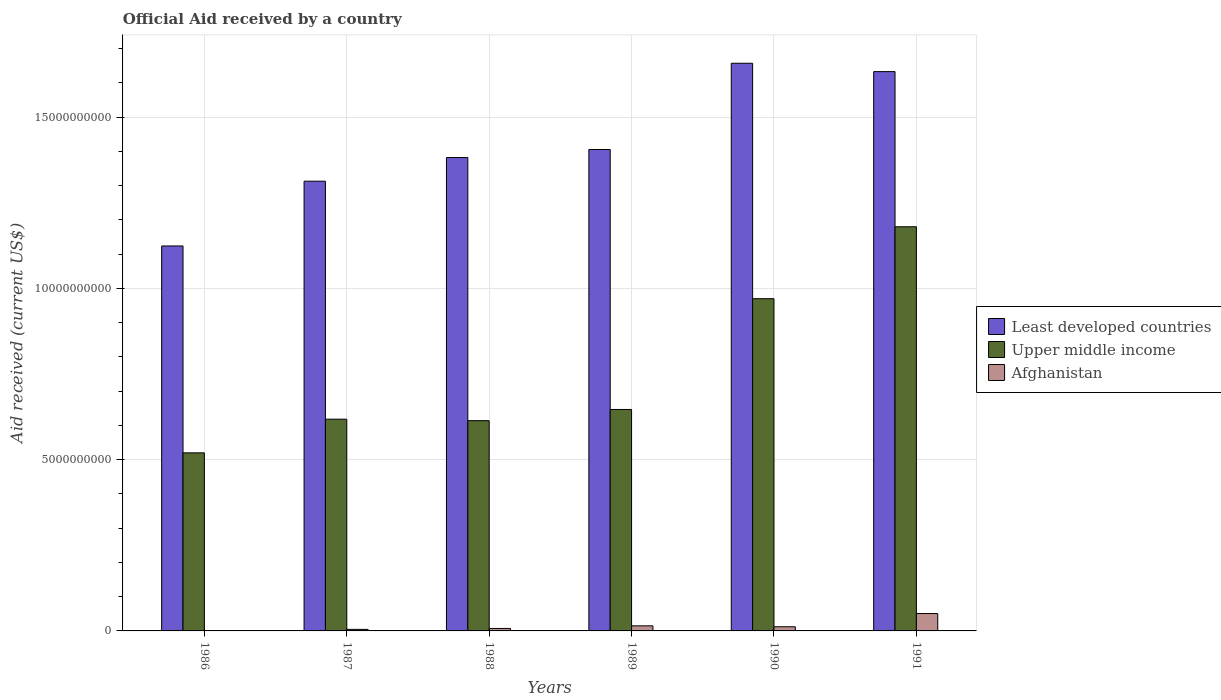How many groups of bars are there?
Your response must be concise. 6. Are the number of bars per tick equal to the number of legend labels?
Provide a succinct answer. Yes. What is the label of the 3rd group of bars from the left?
Make the answer very short. 1988. What is the net official aid received in Upper middle income in 1987?
Provide a short and direct response. 6.18e+09. Across all years, what is the maximum net official aid received in Afghanistan?
Your answer should be very brief. 5.08e+08. Across all years, what is the minimum net official aid received in Upper middle income?
Give a very brief answer. 5.20e+09. In which year was the net official aid received in Least developed countries maximum?
Your response must be concise. 1990. In which year was the net official aid received in Upper middle income minimum?
Your answer should be very brief. 1986. What is the total net official aid received in Afghanistan in the graph?
Make the answer very short. 8.97e+08. What is the difference between the net official aid received in Afghanistan in 1989 and that in 1990?
Keep it short and to the point. 2.66e+07. What is the difference between the net official aid received in Upper middle income in 1986 and the net official aid received in Least developed countries in 1989?
Keep it short and to the point. -8.86e+09. What is the average net official aid received in Upper middle income per year?
Provide a succinct answer. 7.58e+09. In the year 1989, what is the difference between the net official aid received in Afghanistan and net official aid received in Least developed countries?
Ensure brevity in your answer.  -1.39e+1. In how many years, is the net official aid received in Upper middle income greater than 1000000000 US$?
Ensure brevity in your answer.  6. What is the ratio of the net official aid received in Least developed countries in 1987 to that in 1991?
Ensure brevity in your answer.  0.8. What is the difference between the highest and the second highest net official aid received in Upper middle income?
Your response must be concise. 2.10e+09. What is the difference between the highest and the lowest net official aid received in Least developed countries?
Give a very brief answer. 5.34e+09. In how many years, is the net official aid received in Afghanistan greater than the average net official aid received in Afghanistan taken over all years?
Keep it short and to the point. 1. What does the 1st bar from the left in 1990 represents?
Offer a terse response. Least developed countries. What does the 2nd bar from the right in 1988 represents?
Your response must be concise. Upper middle income. How many bars are there?
Your answer should be compact. 18. What is the difference between two consecutive major ticks on the Y-axis?
Make the answer very short. 5.00e+09. How are the legend labels stacked?
Your response must be concise. Vertical. What is the title of the graph?
Your answer should be very brief. Official Aid received by a country. Does "Andorra" appear as one of the legend labels in the graph?
Your response must be concise. No. What is the label or title of the Y-axis?
Your answer should be compact. Aid received (current US$). What is the Aid received (current US$) in Least developed countries in 1986?
Make the answer very short. 1.12e+1. What is the Aid received (current US$) in Upper middle income in 1986?
Offer a very short reply. 5.20e+09. What is the Aid received (current US$) in Afghanistan in 1986?
Offer a terse response. 1.91e+06. What is the Aid received (current US$) of Least developed countries in 1987?
Your response must be concise. 1.31e+1. What is the Aid received (current US$) in Upper middle income in 1987?
Keep it short and to the point. 6.18e+09. What is the Aid received (current US$) in Afghanistan in 1987?
Keep it short and to the point. 4.53e+07. What is the Aid received (current US$) of Least developed countries in 1988?
Keep it short and to the point. 1.38e+1. What is the Aid received (current US$) of Upper middle income in 1988?
Your answer should be very brief. 6.14e+09. What is the Aid received (current US$) of Afghanistan in 1988?
Keep it short and to the point. 7.24e+07. What is the Aid received (current US$) in Least developed countries in 1989?
Provide a succinct answer. 1.41e+1. What is the Aid received (current US$) of Upper middle income in 1989?
Your answer should be compact. 6.47e+09. What is the Aid received (current US$) of Afghanistan in 1989?
Give a very brief answer. 1.48e+08. What is the Aid received (current US$) of Least developed countries in 1990?
Offer a terse response. 1.66e+1. What is the Aid received (current US$) of Upper middle income in 1990?
Your answer should be compact. 9.70e+09. What is the Aid received (current US$) of Afghanistan in 1990?
Ensure brevity in your answer.  1.22e+08. What is the Aid received (current US$) of Least developed countries in 1991?
Your answer should be compact. 1.63e+1. What is the Aid received (current US$) of Upper middle income in 1991?
Provide a short and direct response. 1.18e+1. What is the Aid received (current US$) in Afghanistan in 1991?
Your answer should be very brief. 5.08e+08. Across all years, what is the maximum Aid received (current US$) in Least developed countries?
Make the answer very short. 1.66e+1. Across all years, what is the maximum Aid received (current US$) of Upper middle income?
Your answer should be compact. 1.18e+1. Across all years, what is the maximum Aid received (current US$) in Afghanistan?
Offer a very short reply. 5.08e+08. Across all years, what is the minimum Aid received (current US$) of Least developed countries?
Provide a succinct answer. 1.12e+1. Across all years, what is the minimum Aid received (current US$) in Upper middle income?
Make the answer very short. 5.20e+09. Across all years, what is the minimum Aid received (current US$) in Afghanistan?
Keep it short and to the point. 1.91e+06. What is the total Aid received (current US$) of Least developed countries in the graph?
Make the answer very short. 8.52e+1. What is the total Aid received (current US$) of Upper middle income in the graph?
Your response must be concise. 4.55e+1. What is the total Aid received (current US$) of Afghanistan in the graph?
Provide a short and direct response. 8.97e+08. What is the difference between the Aid received (current US$) of Least developed countries in 1986 and that in 1987?
Your response must be concise. -1.89e+09. What is the difference between the Aid received (current US$) in Upper middle income in 1986 and that in 1987?
Offer a terse response. -9.83e+08. What is the difference between the Aid received (current US$) of Afghanistan in 1986 and that in 1987?
Keep it short and to the point. -4.34e+07. What is the difference between the Aid received (current US$) of Least developed countries in 1986 and that in 1988?
Your answer should be very brief. -2.58e+09. What is the difference between the Aid received (current US$) of Upper middle income in 1986 and that in 1988?
Provide a short and direct response. -9.40e+08. What is the difference between the Aid received (current US$) in Afghanistan in 1986 and that in 1988?
Your answer should be very brief. -7.04e+07. What is the difference between the Aid received (current US$) of Least developed countries in 1986 and that in 1989?
Your answer should be compact. -2.82e+09. What is the difference between the Aid received (current US$) in Upper middle income in 1986 and that in 1989?
Offer a very short reply. -1.27e+09. What is the difference between the Aid received (current US$) of Afghanistan in 1986 and that in 1989?
Keep it short and to the point. -1.46e+08. What is the difference between the Aid received (current US$) in Least developed countries in 1986 and that in 1990?
Provide a short and direct response. -5.34e+09. What is the difference between the Aid received (current US$) of Upper middle income in 1986 and that in 1990?
Keep it short and to the point. -4.50e+09. What is the difference between the Aid received (current US$) of Afghanistan in 1986 and that in 1990?
Make the answer very short. -1.20e+08. What is the difference between the Aid received (current US$) of Least developed countries in 1986 and that in 1991?
Provide a short and direct response. -5.09e+09. What is the difference between the Aid received (current US$) in Upper middle income in 1986 and that in 1991?
Ensure brevity in your answer.  -6.60e+09. What is the difference between the Aid received (current US$) in Afghanistan in 1986 and that in 1991?
Keep it short and to the point. -5.06e+08. What is the difference between the Aid received (current US$) in Least developed countries in 1987 and that in 1988?
Provide a short and direct response. -6.90e+08. What is the difference between the Aid received (current US$) of Upper middle income in 1987 and that in 1988?
Offer a terse response. 4.35e+07. What is the difference between the Aid received (current US$) in Afghanistan in 1987 and that in 1988?
Your response must be concise. -2.71e+07. What is the difference between the Aid received (current US$) of Least developed countries in 1987 and that in 1989?
Offer a very short reply. -9.25e+08. What is the difference between the Aid received (current US$) of Upper middle income in 1987 and that in 1989?
Make the answer very short. -2.83e+08. What is the difference between the Aid received (current US$) of Afghanistan in 1987 and that in 1989?
Offer a terse response. -1.03e+08. What is the difference between the Aid received (current US$) in Least developed countries in 1987 and that in 1990?
Keep it short and to the point. -3.44e+09. What is the difference between the Aid received (current US$) in Upper middle income in 1987 and that in 1990?
Offer a very short reply. -3.52e+09. What is the difference between the Aid received (current US$) in Afghanistan in 1987 and that in 1990?
Your answer should be compact. -7.64e+07. What is the difference between the Aid received (current US$) of Least developed countries in 1987 and that in 1991?
Provide a succinct answer. -3.20e+09. What is the difference between the Aid received (current US$) in Upper middle income in 1987 and that in 1991?
Give a very brief answer. -5.62e+09. What is the difference between the Aid received (current US$) of Afghanistan in 1987 and that in 1991?
Your answer should be very brief. -4.62e+08. What is the difference between the Aid received (current US$) of Least developed countries in 1988 and that in 1989?
Your answer should be compact. -2.35e+08. What is the difference between the Aid received (current US$) in Upper middle income in 1988 and that in 1989?
Provide a short and direct response. -3.26e+08. What is the difference between the Aid received (current US$) in Afghanistan in 1988 and that in 1989?
Your answer should be compact. -7.60e+07. What is the difference between the Aid received (current US$) in Least developed countries in 1988 and that in 1990?
Your response must be concise. -2.75e+09. What is the difference between the Aid received (current US$) in Upper middle income in 1988 and that in 1990?
Offer a terse response. -3.56e+09. What is the difference between the Aid received (current US$) of Afghanistan in 1988 and that in 1990?
Provide a succinct answer. -4.94e+07. What is the difference between the Aid received (current US$) in Least developed countries in 1988 and that in 1991?
Offer a terse response. -2.51e+09. What is the difference between the Aid received (current US$) of Upper middle income in 1988 and that in 1991?
Your response must be concise. -5.66e+09. What is the difference between the Aid received (current US$) of Afghanistan in 1988 and that in 1991?
Offer a very short reply. -4.35e+08. What is the difference between the Aid received (current US$) in Least developed countries in 1989 and that in 1990?
Keep it short and to the point. -2.52e+09. What is the difference between the Aid received (current US$) of Upper middle income in 1989 and that in 1990?
Your response must be concise. -3.23e+09. What is the difference between the Aid received (current US$) of Afghanistan in 1989 and that in 1990?
Provide a short and direct response. 2.66e+07. What is the difference between the Aid received (current US$) of Least developed countries in 1989 and that in 1991?
Give a very brief answer. -2.27e+09. What is the difference between the Aid received (current US$) in Upper middle income in 1989 and that in 1991?
Your answer should be compact. -5.34e+09. What is the difference between the Aid received (current US$) in Afghanistan in 1989 and that in 1991?
Offer a very short reply. -3.59e+08. What is the difference between the Aid received (current US$) of Least developed countries in 1990 and that in 1991?
Your answer should be compact. 2.44e+08. What is the difference between the Aid received (current US$) of Upper middle income in 1990 and that in 1991?
Make the answer very short. -2.10e+09. What is the difference between the Aid received (current US$) of Afghanistan in 1990 and that in 1991?
Your response must be concise. -3.86e+08. What is the difference between the Aid received (current US$) of Least developed countries in 1986 and the Aid received (current US$) of Upper middle income in 1987?
Your response must be concise. 5.06e+09. What is the difference between the Aid received (current US$) in Least developed countries in 1986 and the Aid received (current US$) in Afghanistan in 1987?
Give a very brief answer. 1.12e+1. What is the difference between the Aid received (current US$) of Upper middle income in 1986 and the Aid received (current US$) of Afghanistan in 1987?
Your answer should be very brief. 5.15e+09. What is the difference between the Aid received (current US$) of Least developed countries in 1986 and the Aid received (current US$) of Upper middle income in 1988?
Provide a short and direct response. 5.10e+09. What is the difference between the Aid received (current US$) in Least developed countries in 1986 and the Aid received (current US$) in Afghanistan in 1988?
Your answer should be very brief. 1.12e+1. What is the difference between the Aid received (current US$) in Upper middle income in 1986 and the Aid received (current US$) in Afghanistan in 1988?
Give a very brief answer. 5.13e+09. What is the difference between the Aid received (current US$) of Least developed countries in 1986 and the Aid received (current US$) of Upper middle income in 1989?
Provide a short and direct response. 4.77e+09. What is the difference between the Aid received (current US$) of Least developed countries in 1986 and the Aid received (current US$) of Afghanistan in 1989?
Make the answer very short. 1.11e+1. What is the difference between the Aid received (current US$) in Upper middle income in 1986 and the Aid received (current US$) in Afghanistan in 1989?
Give a very brief answer. 5.05e+09. What is the difference between the Aid received (current US$) in Least developed countries in 1986 and the Aid received (current US$) in Upper middle income in 1990?
Provide a succinct answer. 1.54e+09. What is the difference between the Aid received (current US$) in Least developed countries in 1986 and the Aid received (current US$) in Afghanistan in 1990?
Ensure brevity in your answer.  1.11e+1. What is the difference between the Aid received (current US$) in Upper middle income in 1986 and the Aid received (current US$) in Afghanistan in 1990?
Offer a terse response. 5.08e+09. What is the difference between the Aid received (current US$) of Least developed countries in 1986 and the Aid received (current US$) of Upper middle income in 1991?
Offer a terse response. -5.61e+08. What is the difference between the Aid received (current US$) in Least developed countries in 1986 and the Aid received (current US$) in Afghanistan in 1991?
Ensure brevity in your answer.  1.07e+1. What is the difference between the Aid received (current US$) of Upper middle income in 1986 and the Aid received (current US$) of Afghanistan in 1991?
Keep it short and to the point. 4.69e+09. What is the difference between the Aid received (current US$) of Least developed countries in 1987 and the Aid received (current US$) of Upper middle income in 1988?
Make the answer very short. 6.99e+09. What is the difference between the Aid received (current US$) of Least developed countries in 1987 and the Aid received (current US$) of Afghanistan in 1988?
Offer a terse response. 1.31e+1. What is the difference between the Aid received (current US$) in Upper middle income in 1987 and the Aid received (current US$) in Afghanistan in 1988?
Keep it short and to the point. 6.11e+09. What is the difference between the Aid received (current US$) in Least developed countries in 1987 and the Aid received (current US$) in Upper middle income in 1989?
Give a very brief answer. 6.67e+09. What is the difference between the Aid received (current US$) in Least developed countries in 1987 and the Aid received (current US$) in Afghanistan in 1989?
Keep it short and to the point. 1.30e+1. What is the difference between the Aid received (current US$) in Upper middle income in 1987 and the Aid received (current US$) in Afghanistan in 1989?
Provide a succinct answer. 6.03e+09. What is the difference between the Aid received (current US$) of Least developed countries in 1987 and the Aid received (current US$) of Upper middle income in 1990?
Provide a succinct answer. 3.43e+09. What is the difference between the Aid received (current US$) in Least developed countries in 1987 and the Aid received (current US$) in Afghanistan in 1990?
Your answer should be compact. 1.30e+1. What is the difference between the Aid received (current US$) of Upper middle income in 1987 and the Aid received (current US$) of Afghanistan in 1990?
Provide a succinct answer. 6.06e+09. What is the difference between the Aid received (current US$) of Least developed countries in 1987 and the Aid received (current US$) of Upper middle income in 1991?
Your answer should be very brief. 1.33e+09. What is the difference between the Aid received (current US$) of Least developed countries in 1987 and the Aid received (current US$) of Afghanistan in 1991?
Keep it short and to the point. 1.26e+1. What is the difference between the Aid received (current US$) in Upper middle income in 1987 and the Aid received (current US$) in Afghanistan in 1991?
Give a very brief answer. 5.68e+09. What is the difference between the Aid received (current US$) in Least developed countries in 1988 and the Aid received (current US$) in Upper middle income in 1989?
Your answer should be very brief. 7.36e+09. What is the difference between the Aid received (current US$) in Least developed countries in 1988 and the Aid received (current US$) in Afghanistan in 1989?
Your answer should be compact. 1.37e+1. What is the difference between the Aid received (current US$) in Upper middle income in 1988 and the Aid received (current US$) in Afghanistan in 1989?
Your response must be concise. 5.99e+09. What is the difference between the Aid received (current US$) of Least developed countries in 1988 and the Aid received (current US$) of Upper middle income in 1990?
Provide a succinct answer. 4.12e+09. What is the difference between the Aid received (current US$) of Least developed countries in 1988 and the Aid received (current US$) of Afghanistan in 1990?
Ensure brevity in your answer.  1.37e+1. What is the difference between the Aid received (current US$) in Upper middle income in 1988 and the Aid received (current US$) in Afghanistan in 1990?
Your answer should be very brief. 6.02e+09. What is the difference between the Aid received (current US$) in Least developed countries in 1988 and the Aid received (current US$) in Upper middle income in 1991?
Offer a terse response. 2.02e+09. What is the difference between the Aid received (current US$) in Least developed countries in 1988 and the Aid received (current US$) in Afghanistan in 1991?
Your response must be concise. 1.33e+1. What is the difference between the Aid received (current US$) of Upper middle income in 1988 and the Aid received (current US$) of Afghanistan in 1991?
Offer a very short reply. 5.63e+09. What is the difference between the Aid received (current US$) in Least developed countries in 1989 and the Aid received (current US$) in Upper middle income in 1990?
Your response must be concise. 4.36e+09. What is the difference between the Aid received (current US$) in Least developed countries in 1989 and the Aid received (current US$) in Afghanistan in 1990?
Your answer should be very brief. 1.39e+1. What is the difference between the Aid received (current US$) in Upper middle income in 1989 and the Aid received (current US$) in Afghanistan in 1990?
Offer a very short reply. 6.34e+09. What is the difference between the Aid received (current US$) in Least developed countries in 1989 and the Aid received (current US$) in Upper middle income in 1991?
Provide a succinct answer. 2.26e+09. What is the difference between the Aid received (current US$) in Least developed countries in 1989 and the Aid received (current US$) in Afghanistan in 1991?
Give a very brief answer. 1.36e+1. What is the difference between the Aid received (current US$) of Upper middle income in 1989 and the Aid received (current US$) of Afghanistan in 1991?
Provide a short and direct response. 5.96e+09. What is the difference between the Aid received (current US$) in Least developed countries in 1990 and the Aid received (current US$) in Upper middle income in 1991?
Your answer should be compact. 4.77e+09. What is the difference between the Aid received (current US$) of Least developed countries in 1990 and the Aid received (current US$) of Afghanistan in 1991?
Provide a succinct answer. 1.61e+1. What is the difference between the Aid received (current US$) in Upper middle income in 1990 and the Aid received (current US$) in Afghanistan in 1991?
Your answer should be very brief. 9.19e+09. What is the average Aid received (current US$) in Least developed countries per year?
Your answer should be very brief. 1.42e+1. What is the average Aid received (current US$) of Upper middle income per year?
Keep it short and to the point. 7.58e+09. What is the average Aid received (current US$) in Afghanistan per year?
Offer a very short reply. 1.50e+08. In the year 1986, what is the difference between the Aid received (current US$) in Least developed countries and Aid received (current US$) in Upper middle income?
Ensure brevity in your answer.  6.04e+09. In the year 1986, what is the difference between the Aid received (current US$) in Least developed countries and Aid received (current US$) in Afghanistan?
Keep it short and to the point. 1.12e+1. In the year 1986, what is the difference between the Aid received (current US$) in Upper middle income and Aid received (current US$) in Afghanistan?
Offer a very short reply. 5.20e+09. In the year 1987, what is the difference between the Aid received (current US$) in Least developed countries and Aid received (current US$) in Upper middle income?
Give a very brief answer. 6.95e+09. In the year 1987, what is the difference between the Aid received (current US$) in Least developed countries and Aid received (current US$) in Afghanistan?
Offer a very short reply. 1.31e+1. In the year 1987, what is the difference between the Aid received (current US$) in Upper middle income and Aid received (current US$) in Afghanistan?
Your response must be concise. 6.14e+09. In the year 1988, what is the difference between the Aid received (current US$) in Least developed countries and Aid received (current US$) in Upper middle income?
Your answer should be compact. 7.68e+09. In the year 1988, what is the difference between the Aid received (current US$) of Least developed countries and Aid received (current US$) of Afghanistan?
Give a very brief answer. 1.38e+1. In the year 1988, what is the difference between the Aid received (current US$) of Upper middle income and Aid received (current US$) of Afghanistan?
Offer a very short reply. 6.07e+09. In the year 1989, what is the difference between the Aid received (current US$) of Least developed countries and Aid received (current US$) of Upper middle income?
Offer a very short reply. 7.59e+09. In the year 1989, what is the difference between the Aid received (current US$) in Least developed countries and Aid received (current US$) in Afghanistan?
Offer a very short reply. 1.39e+1. In the year 1989, what is the difference between the Aid received (current US$) of Upper middle income and Aid received (current US$) of Afghanistan?
Your answer should be very brief. 6.32e+09. In the year 1990, what is the difference between the Aid received (current US$) in Least developed countries and Aid received (current US$) in Upper middle income?
Your answer should be very brief. 6.88e+09. In the year 1990, what is the difference between the Aid received (current US$) in Least developed countries and Aid received (current US$) in Afghanistan?
Keep it short and to the point. 1.65e+1. In the year 1990, what is the difference between the Aid received (current US$) of Upper middle income and Aid received (current US$) of Afghanistan?
Your response must be concise. 9.58e+09. In the year 1991, what is the difference between the Aid received (current US$) of Least developed countries and Aid received (current US$) of Upper middle income?
Offer a very short reply. 4.53e+09. In the year 1991, what is the difference between the Aid received (current US$) of Least developed countries and Aid received (current US$) of Afghanistan?
Give a very brief answer. 1.58e+1. In the year 1991, what is the difference between the Aid received (current US$) in Upper middle income and Aid received (current US$) in Afghanistan?
Your answer should be very brief. 1.13e+1. What is the ratio of the Aid received (current US$) in Least developed countries in 1986 to that in 1987?
Your answer should be very brief. 0.86. What is the ratio of the Aid received (current US$) of Upper middle income in 1986 to that in 1987?
Make the answer very short. 0.84. What is the ratio of the Aid received (current US$) in Afghanistan in 1986 to that in 1987?
Give a very brief answer. 0.04. What is the ratio of the Aid received (current US$) of Least developed countries in 1986 to that in 1988?
Your response must be concise. 0.81. What is the ratio of the Aid received (current US$) of Upper middle income in 1986 to that in 1988?
Offer a very short reply. 0.85. What is the ratio of the Aid received (current US$) of Afghanistan in 1986 to that in 1988?
Give a very brief answer. 0.03. What is the ratio of the Aid received (current US$) of Least developed countries in 1986 to that in 1989?
Provide a succinct answer. 0.8. What is the ratio of the Aid received (current US$) of Upper middle income in 1986 to that in 1989?
Give a very brief answer. 0.8. What is the ratio of the Aid received (current US$) of Afghanistan in 1986 to that in 1989?
Offer a very short reply. 0.01. What is the ratio of the Aid received (current US$) in Least developed countries in 1986 to that in 1990?
Your answer should be compact. 0.68. What is the ratio of the Aid received (current US$) of Upper middle income in 1986 to that in 1990?
Provide a succinct answer. 0.54. What is the ratio of the Aid received (current US$) in Afghanistan in 1986 to that in 1990?
Offer a very short reply. 0.02. What is the ratio of the Aid received (current US$) in Least developed countries in 1986 to that in 1991?
Ensure brevity in your answer.  0.69. What is the ratio of the Aid received (current US$) in Upper middle income in 1986 to that in 1991?
Your answer should be very brief. 0.44. What is the ratio of the Aid received (current US$) in Afghanistan in 1986 to that in 1991?
Offer a terse response. 0. What is the ratio of the Aid received (current US$) in Least developed countries in 1987 to that in 1988?
Ensure brevity in your answer.  0.95. What is the ratio of the Aid received (current US$) of Upper middle income in 1987 to that in 1988?
Your answer should be compact. 1.01. What is the ratio of the Aid received (current US$) in Afghanistan in 1987 to that in 1988?
Ensure brevity in your answer.  0.63. What is the ratio of the Aid received (current US$) of Least developed countries in 1987 to that in 1989?
Your answer should be very brief. 0.93. What is the ratio of the Aid received (current US$) of Upper middle income in 1987 to that in 1989?
Offer a terse response. 0.96. What is the ratio of the Aid received (current US$) in Afghanistan in 1987 to that in 1989?
Provide a short and direct response. 0.31. What is the ratio of the Aid received (current US$) of Least developed countries in 1987 to that in 1990?
Keep it short and to the point. 0.79. What is the ratio of the Aid received (current US$) of Upper middle income in 1987 to that in 1990?
Offer a very short reply. 0.64. What is the ratio of the Aid received (current US$) of Afghanistan in 1987 to that in 1990?
Keep it short and to the point. 0.37. What is the ratio of the Aid received (current US$) in Least developed countries in 1987 to that in 1991?
Ensure brevity in your answer.  0.8. What is the ratio of the Aid received (current US$) in Upper middle income in 1987 to that in 1991?
Ensure brevity in your answer.  0.52. What is the ratio of the Aid received (current US$) in Afghanistan in 1987 to that in 1991?
Provide a succinct answer. 0.09. What is the ratio of the Aid received (current US$) in Least developed countries in 1988 to that in 1989?
Make the answer very short. 0.98. What is the ratio of the Aid received (current US$) of Upper middle income in 1988 to that in 1989?
Offer a very short reply. 0.95. What is the ratio of the Aid received (current US$) in Afghanistan in 1988 to that in 1989?
Your answer should be compact. 0.49. What is the ratio of the Aid received (current US$) of Least developed countries in 1988 to that in 1990?
Offer a very short reply. 0.83. What is the ratio of the Aid received (current US$) in Upper middle income in 1988 to that in 1990?
Your answer should be compact. 0.63. What is the ratio of the Aid received (current US$) of Afghanistan in 1988 to that in 1990?
Give a very brief answer. 0.59. What is the ratio of the Aid received (current US$) in Least developed countries in 1988 to that in 1991?
Your answer should be compact. 0.85. What is the ratio of the Aid received (current US$) of Upper middle income in 1988 to that in 1991?
Make the answer very short. 0.52. What is the ratio of the Aid received (current US$) of Afghanistan in 1988 to that in 1991?
Offer a terse response. 0.14. What is the ratio of the Aid received (current US$) in Least developed countries in 1989 to that in 1990?
Provide a short and direct response. 0.85. What is the ratio of the Aid received (current US$) in Upper middle income in 1989 to that in 1990?
Your answer should be compact. 0.67. What is the ratio of the Aid received (current US$) in Afghanistan in 1989 to that in 1990?
Offer a terse response. 1.22. What is the ratio of the Aid received (current US$) in Least developed countries in 1989 to that in 1991?
Your answer should be compact. 0.86. What is the ratio of the Aid received (current US$) in Upper middle income in 1989 to that in 1991?
Your response must be concise. 0.55. What is the ratio of the Aid received (current US$) in Afghanistan in 1989 to that in 1991?
Your response must be concise. 0.29. What is the ratio of the Aid received (current US$) in Least developed countries in 1990 to that in 1991?
Your response must be concise. 1.01. What is the ratio of the Aid received (current US$) in Upper middle income in 1990 to that in 1991?
Keep it short and to the point. 0.82. What is the ratio of the Aid received (current US$) of Afghanistan in 1990 to that in 1991?
Ensure brevity in your answer.  0.24. What is the difference between the highest and the second highest Aid received (current US$) of Least developed countries?
Offer a very short reply. 2.44e+08. What is the difference between the highest and the second highest Aid received (current US$) in Upper middle income?
Provide a succinct answer. 2.10e+09. What is the difference between the highest and the second highest Aid received (current US$) of Afghanistan?
Provide a short and direct response. 3.59e+08. What is the difference between the highest and the lowest Aid received (current US$) in Least developed countries?
Your response must be concise. 5.34e+09. What is the difference between the highest and the lowest Aid received (current US$) in Upper middle income?
Make the answer very short. 6.60e+09. What is the difference between the highest and the lowest Aid received (current US$) of Afghanistan?
Offer a very short reply. 5.06e+08. 